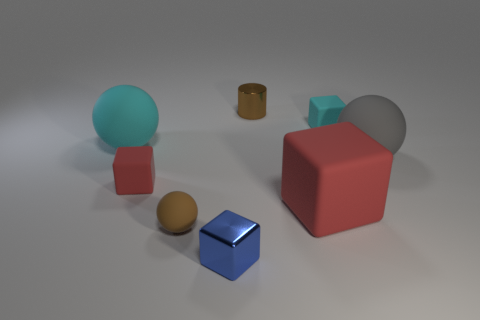Subtract all red cubes. How many were subtracted if there are1red cubes left? 1 Subtract all cyan blocks. How many blocks are left? 3 Subtract all brown blocks. Subtract all blue spheres. How many blocks are left? 4 Add 2 small yellow rubber spheres. How many objects exist? 10 Subtract all balls. How many objects are left? 5 Add 3 tiny things. How many tiny things are left? 8 Add 6 red rubber things. How many red rubber things exist? 8 Subtract 0 yellow cylinders. How many objects are left? 8 Subtract all small brown shiny cylinders. Subtract all large matte things. How many objects are left? 4 